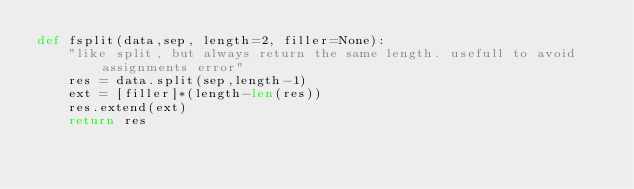<code> <loc_0><loc_0><loc_500><loc_500><_Python_>def fsplit(data,sep, length=2, filler=None):
    "like split, but always return the same length. usefull to avoid assignments error"
    res = data.split(sep,length-1)
    ext = [filler]*(length-len(res))
    res.extend(ext)
    return res
</code> 